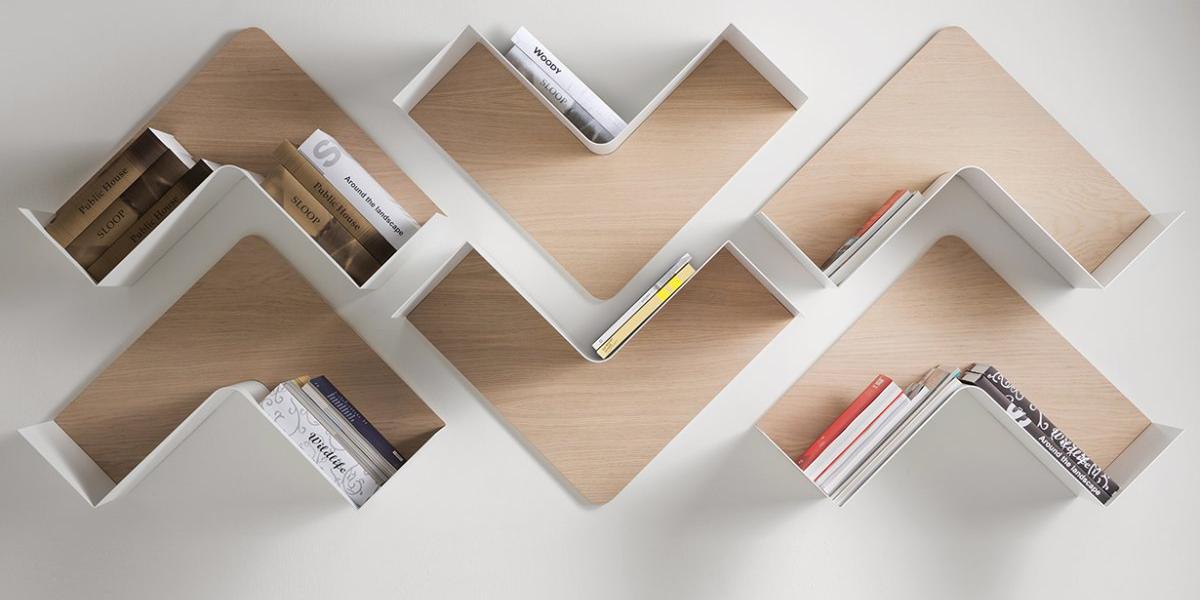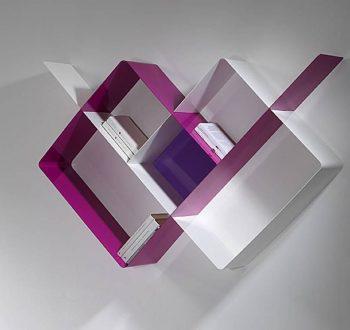The first image is the image on the left, the second image is the image on the right. Given the left and right images, does the statement "Each shelf unit holds some type of items, and one of the units has a single horizontal shelf." hold true? Answer yes or no. No. The first image is the image on the left, the second image is the image on the right. Examine the images to the left and right. Is the description "The shelf in one of the images is completely black." accurate? Answer yes or no. No. 